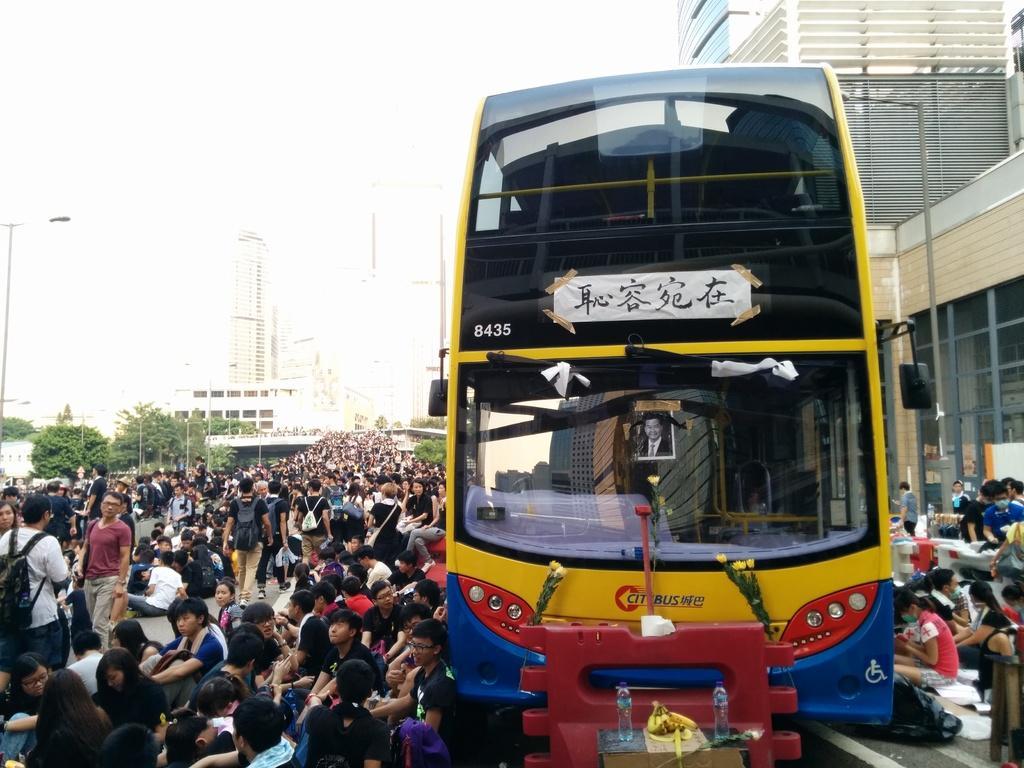Please provide a concise description of this image. In this image we can see bus and persons on the road. In the background we can see buildings, poles, trees and sky. 